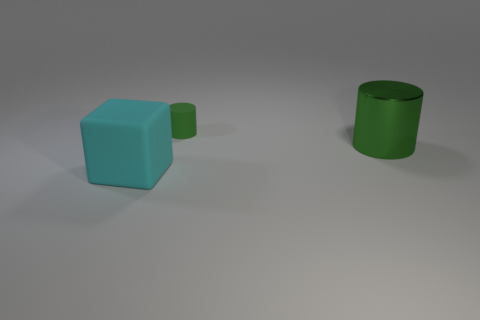What do the colors of the objects tell us about the mood or setting of the scene? The use of cool colors such as cyan for the block and shades of green for the cylinders creates a calm and composed ambiance. These colors are often associated with serenity and stability, which could suggest a tranquil and simplistic setting for the scene. 